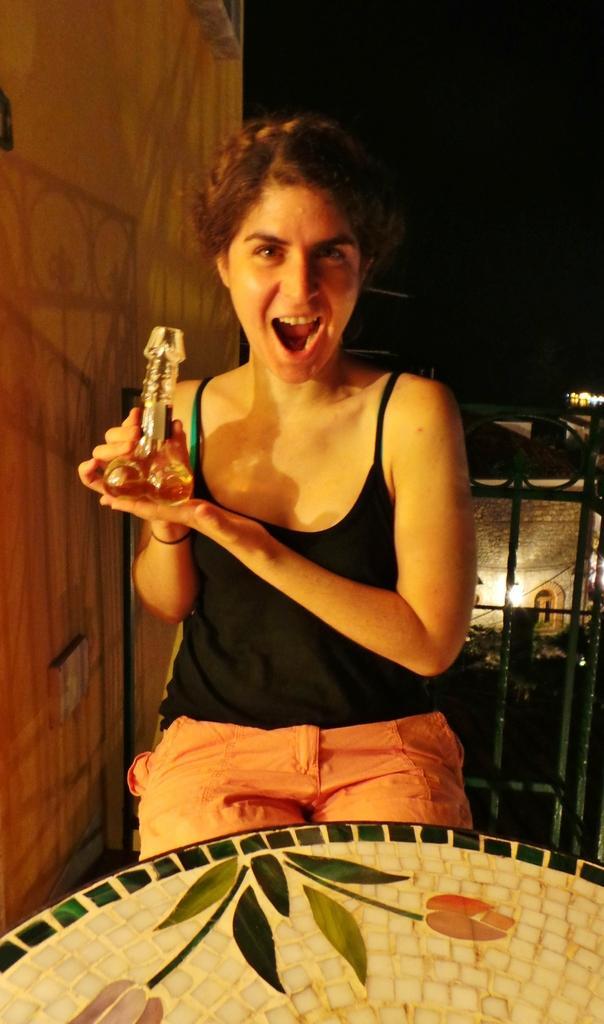In one or two sentences, can you explain what this image depicts? At the bottom of the image there is an object with designs on flowers and leaves. Behind that object there is a lady sitting and holding a glass bottle in her hand. On the left side of the image there is a wall. Behind the lady there is a fencing. Behind the fencing there are plants and wall with a window and a light. 